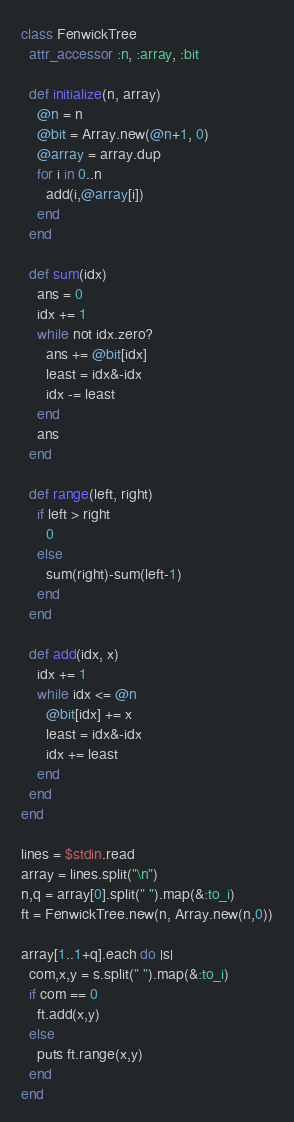Convert code to text. <code><loc_0><loc_0><loc_500><loc_500><_Ruby_>class FenwickTree
  attr_accessor :n, :array, :bit

  def initialize(n, array)
    @n = n
    @bit = Array.new(@n+1, 0)
    @array = array.dup
    for i in 0..n
      add(i,@array[i])
    end
  end

  def sum(idx)
    ans = 0
    idx += 1
    while not idx.zero?
      ans += @bit[idx]
      least = idx&-idx
      idx -= least
    end
    ans
  end

  def range(left, right)
    if left > right
      0
    else
      sum(right)-sum(left-1)
    end
  end

  def add(idx, x)
    idx += 1
    while idx <= @n
      @bit[idx] += x
      least = idx&-idx
      idx += least
    end
  end
end

lines = $stdin.read
array = lines.split("\n")
n,q = array[0].split(" ").map(&:to_i)
ft = FenwickTree.new(n, Array.new(n,0))

array[1..1+q].each do |s|
  com,x,y = s.split(" ").map(&:to_i)
  if com == 0
    ft.add(x,y)
  else
    puts ft.range(x,y)
  end
end
</code> 